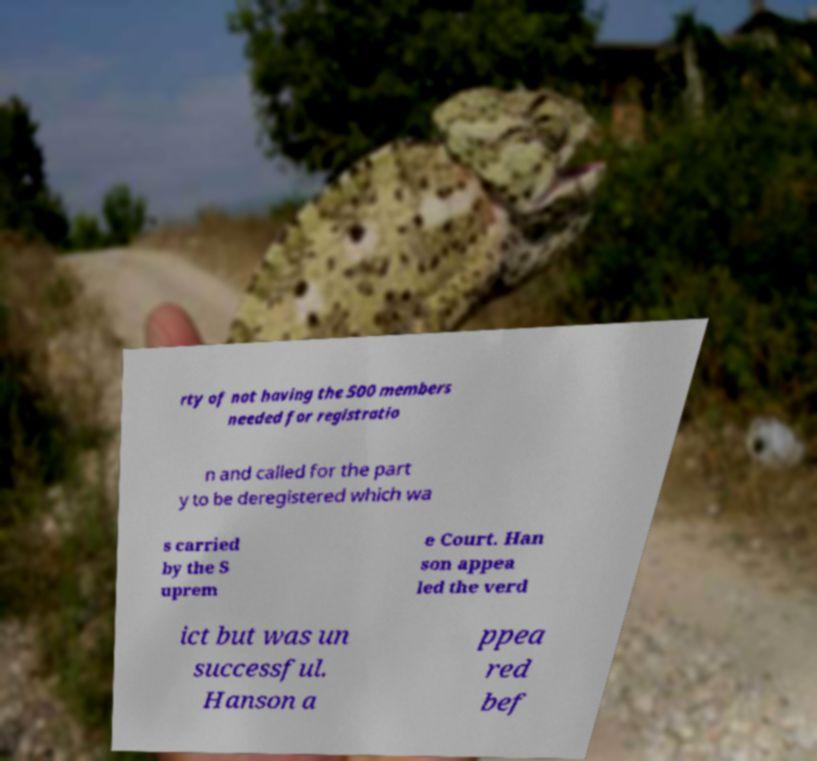Could you extract and type out the text from this image? rty of not having the 500 members needed for registratio n and called for the part y to be deregistered which wa s carried by the S uprem e Court. Han son appea led the verd ict but was un successful. Hanson a ppea red bef 